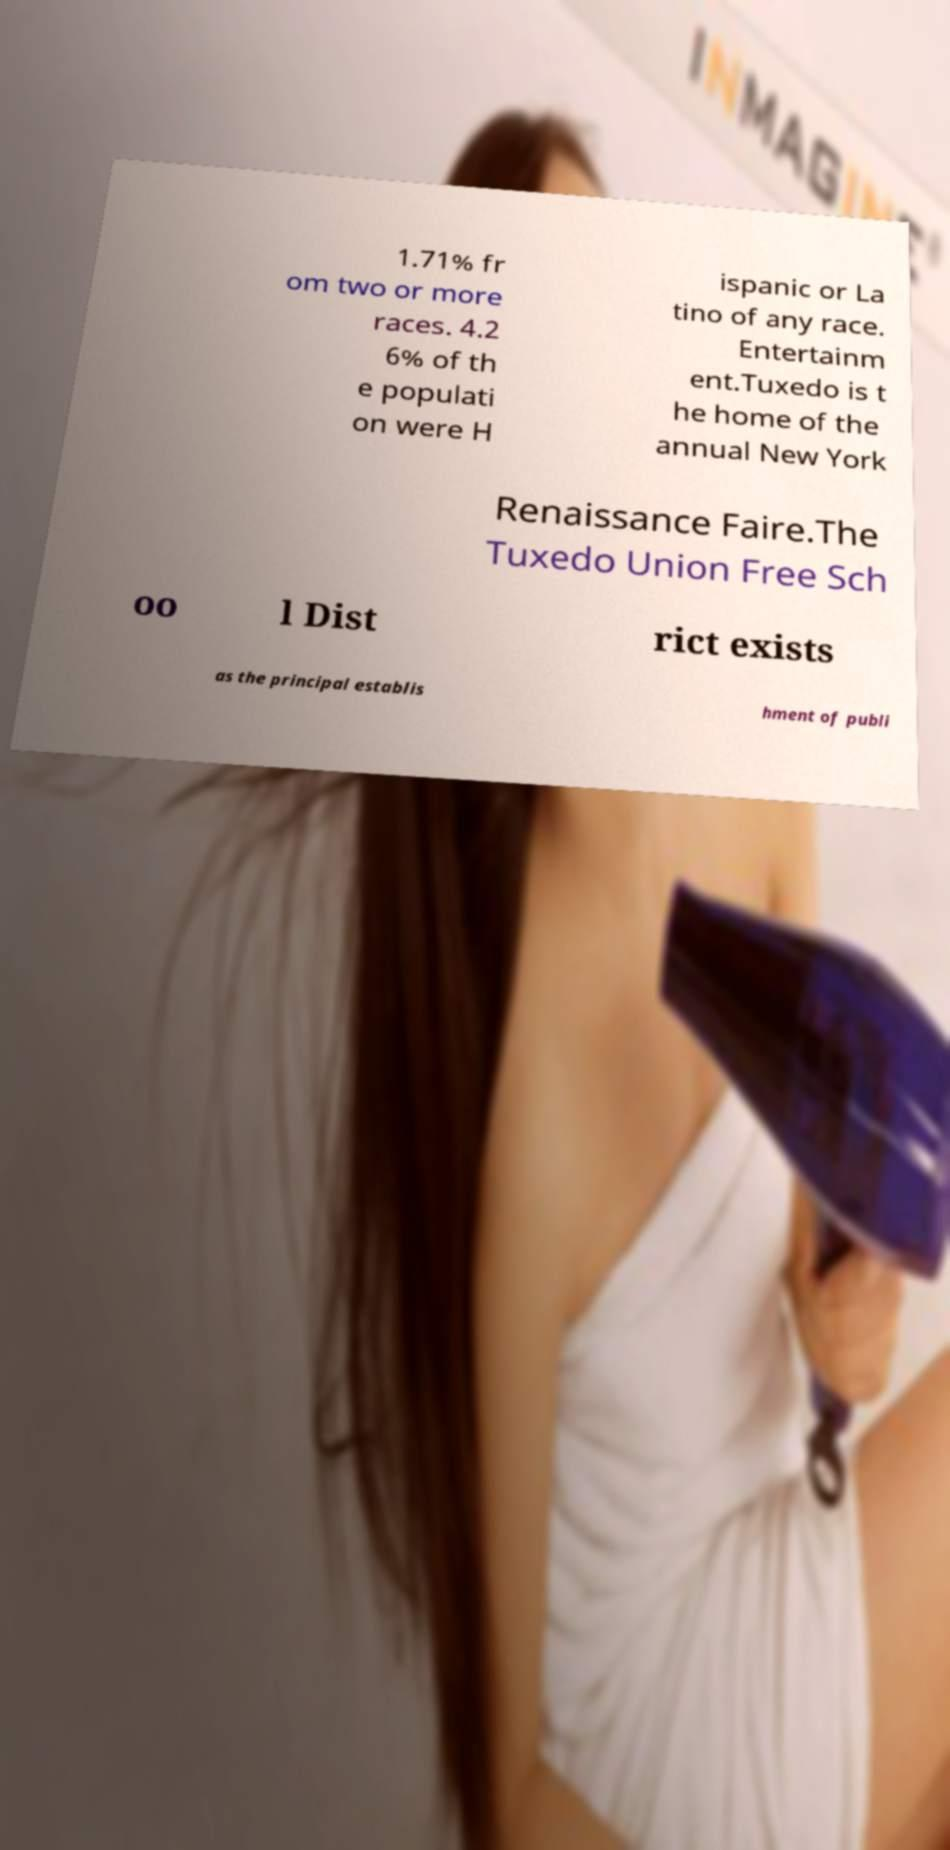I need the written content from this picture converted into text. Can you do that? 1.71% fr om two or more races. 4.2 6% of th e populati on were H ispanic or La tino of any race. Entertainm ent.Tuxedo is t he home of the annual New York Renaissance Faire.The Tuxedo Union Free Sch oo l Dist rict exists as the principal establis hment of publi 